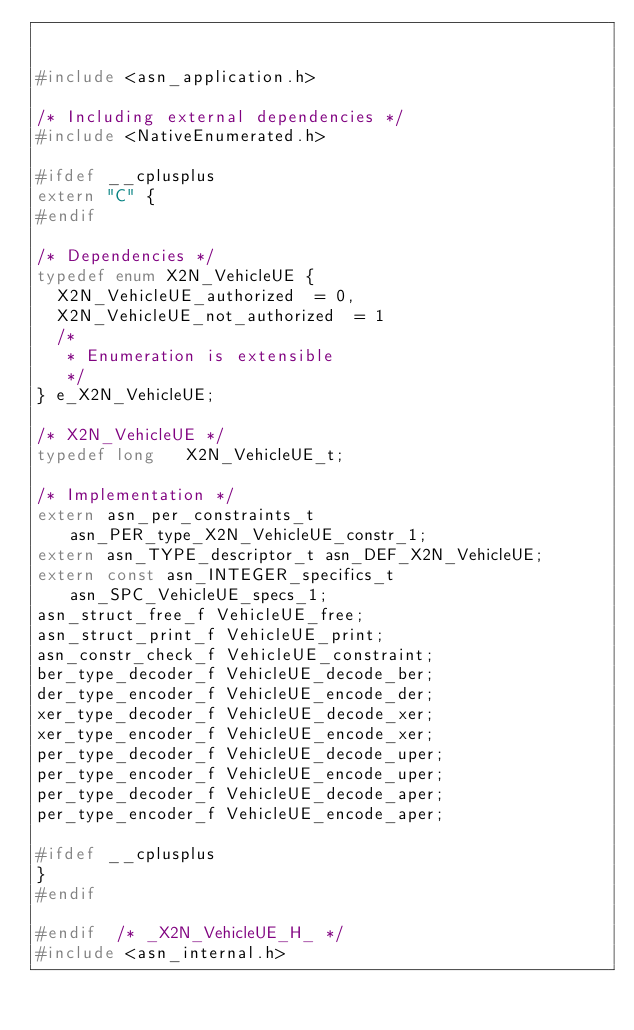Convert code to text. <code><loc_0><loc_0><loc_500><loc_500><_C_>

#include <asn_application.h>

/* Including external dependencies */
#include <NativeEnumerated.h>

#ifdef __cplusplus
extern "C" {
#endif

/* Dependencies */
typedef enum X2N_VehicleUE {
	X2N_VehicleUE_authorized	= 0,
	X2N_VehicleUE_not_authorized	= 1
	/*
	 * Enumeration is extensible
	 */
} e_X2N_VehicleUE;

/* X2N_VehicleUE */
typedef long	 X2N_VehicleUE_t;

/* Implementation */
extern asn_per_constraints_t asn_PER_type_X2N_VehicleUE_constr_1;
extern asn_TYPE_descriptor_t asn_DEF_X2N_VehicleUE;
extern const asn_INTEGER_specifics_t asn_SPC_VehicleUE_specs_1;
asn_struct_free_f VehicleUE_free;
asn_struct_print_f VehicleUE_print;
asn_constr_check_f VehicleUE_constraint;
ber_type_decoder_f VehicleUE_decode_ber;
der_type_encoder_f VehicleUE_encode_der;
xer_type_decoder_f VehicleUE_decode_xer;
xer_type_encoder_f VehicleUE_encode_xer;
per_type_decoder_f VehicleUE_decode_uper;
per_type_encoder_f VehicleUE_encode_uper;
per_type_decoder_f VehicleUE_decode_aper;
per_type_encoder_f VehicleUE_encode_aper;

#ifdef __cplusplus
}
#endif

#endif	/* _X2N_VehicleUE_H_ */
#include <asn_internal.h>
</code> 